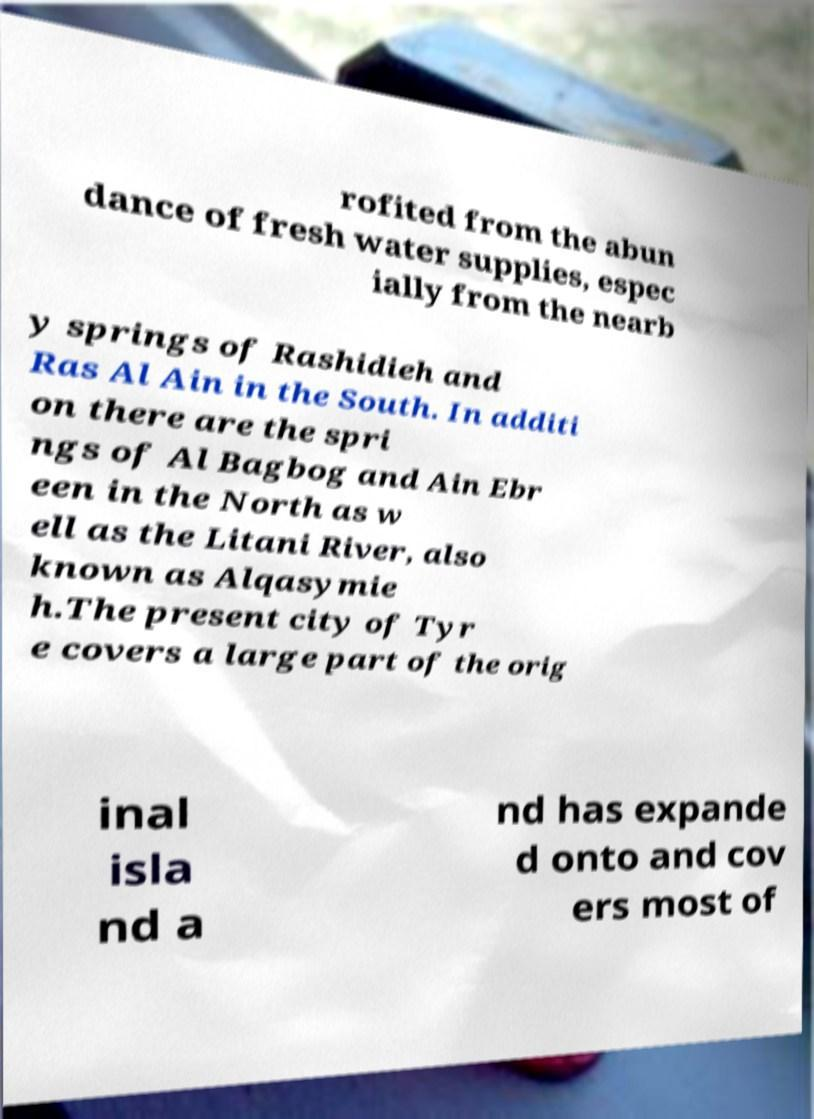Can you accurately transcribe the text from the provided image for me? rofited from the abun dance of fresh water supplies, espec ially from the nearb y springs of Rashidieh and Ras Al Ain in the South. In additi on there are the spri ngs of Al Bagbog and Ain Ebr een in the North as w ell as the Litani River, also known as Alqasymie h.The present city of Tyr e covers a large part of the orig inal isla nd a nd has expande d onto and cov ers most of 